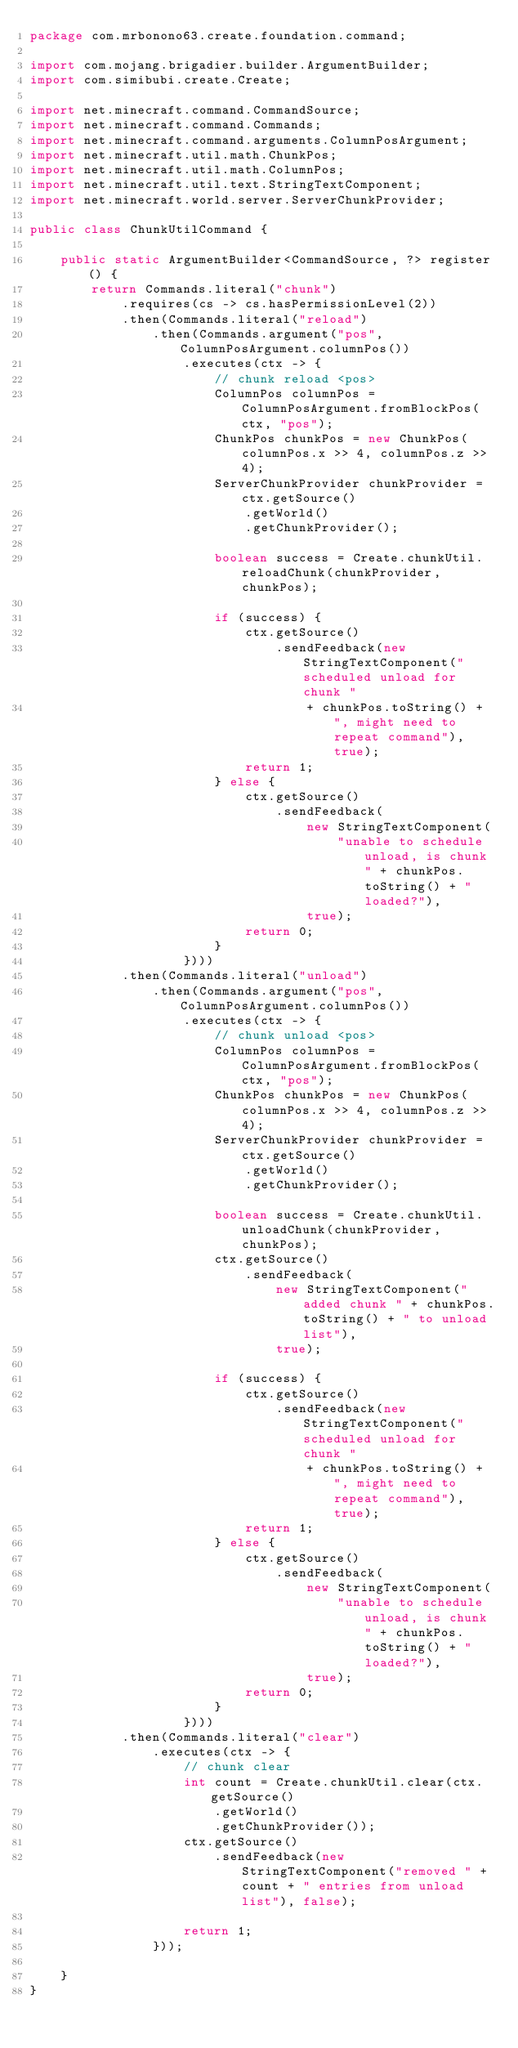Convert code to text. <code><loc_0><loc_0><loc_500><loc_500><_Java_>package com.mrbonono63.create.foundation.command;

import com.mojang.brigadier.builder.ArgumentBuilder;
import com.simibubi.create.Create;

import net.minecraft.command.CommandSource;
import net.minecraft.command.Commands;
import net.minecraft.command.arguments.ColumnPosArgument;
import net.minecraft.util.math.ChunkPos;
import net.minecraft.util.math.ColumnPos;
import net.minecraft.util.text.StringTextComponent;
import net.minecraft.world.server.ServerChunkProvider;

public class ChunkUtilCommand {

	public static ArgumentBuilder<CommandSource, ?> register() {
		return Commands.literal("chunk")
			.requires(cs -> cs.hasPermissionLevel(2))
			.then(Commands.literal("reload")
				.then(Commands.argument("pos", ColumnPosArgument.columnPos())
					.executes(ctx -> {
						// chunk reload <pos>
						ColumnPos columnPos = ColumnPosArgument.fromBlockPos(ctx, "pos");
						ChunkPos chunkPos = new ChunkPos(columnPos.x >> 4, columnPos.z >> 4);
						ServerChunkProvider chunkProvider = ctx.getSource()
							.getWorld()
							.getChunkProvider();

						boolean success = Create.chunkUtil.reloadChunk(chunkProvider, chunkPos);

						if (success) {
							ctx.getSource()
								.sendFeedback(new StringTextComponent("scheduled unload for chunk "
									+ chunkPos.toString() + ", might need to repeat command"), true);
							return 1;
						} else {
							ctx.getSource()
								.sendFeedback(
									new StringTextComponent(
										"unable to schedule unload, is chunk " + chunkPos.toString() + " loaded?"),
									true);
							return 0;
						}
					})))
			.then(Commands.literal("unload")
				.then(Commands.argument("pos", ColumnPosArgument.columnPos())
					.executes(ctx -> {
						// chunk unload <pos>
						ColumnPos columnPos = ColumnPosArgument.fromBlockPos(ctx, "pos");
						ChunkPos chunkPos = new ChunkPos(columnPos.x >> 4, columnPos.z >> 4);
						ServerChunkProvider chunkProvider = ctx.getSource()
							.getWorld()
							.getChunkProvider();

						boolean success = Create.chunkUtil.unloadChunk(chunkProvider, chunkPos);
						ctx.getSource()
							.sendFeedback(
								new StringTextComponent("added chunk " + chunkPos.toString() + " to unload list"),
								true);

						if (success) {
							ctx.getSource()
								.sendFeedback(new StringTextComponent("scheduled unload for chunk "
									+ chunkPos.toString() + ", might need to repeat command"), true);
							return 1;
						} else {
							ctx.getSource()
								.sendFeedback(
									new StringTextComponent(
										"unable to schedule unload, is chunk " + chunkPos.toString() + " loaded?"),
									true);
							return 0;
						}
					})))
			.then(Commands.literal("clear")
				.executes(ctx -> {
					// chunk clear
					int count = Create.chunkUtil.clear(ctx.getSource()
						.getWorld()
						.getChunkProvider());
					ctx.getSource()
						.sendFeedback(new StringTextComponent("removed " + count + " entries from unload list"), false);

					return 1;
				}));

	}
}
</code> 